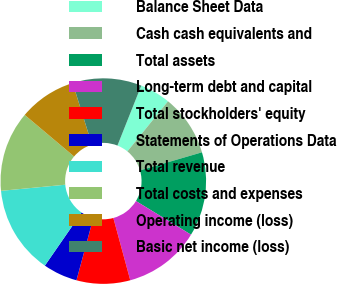Convert chart. <chart><loc_0><loc_0><loc_500><loc_500><pie_chart><fcel>Balance Sheet Data<fcel>Cash cash equivalents and<fcel>Total assets<fcel>Long-term debt and capital<fcel>Total stockholders' equity<fcel>Statements of Operations Data<fcel>Total revenue<fcel>Total costs and expenses<fcel>Operating income (loss)<fcel>Basic net income (loss)<nl><fcel>4.82%<fcel>9.64%<fcel>13.25%<fcel>12.05%<fcel>8.43%<fcel>5.42%<fcel>13.86%<fcel>12.65%<fcel>9.04%<fcel>10.84%<nl></chart> 